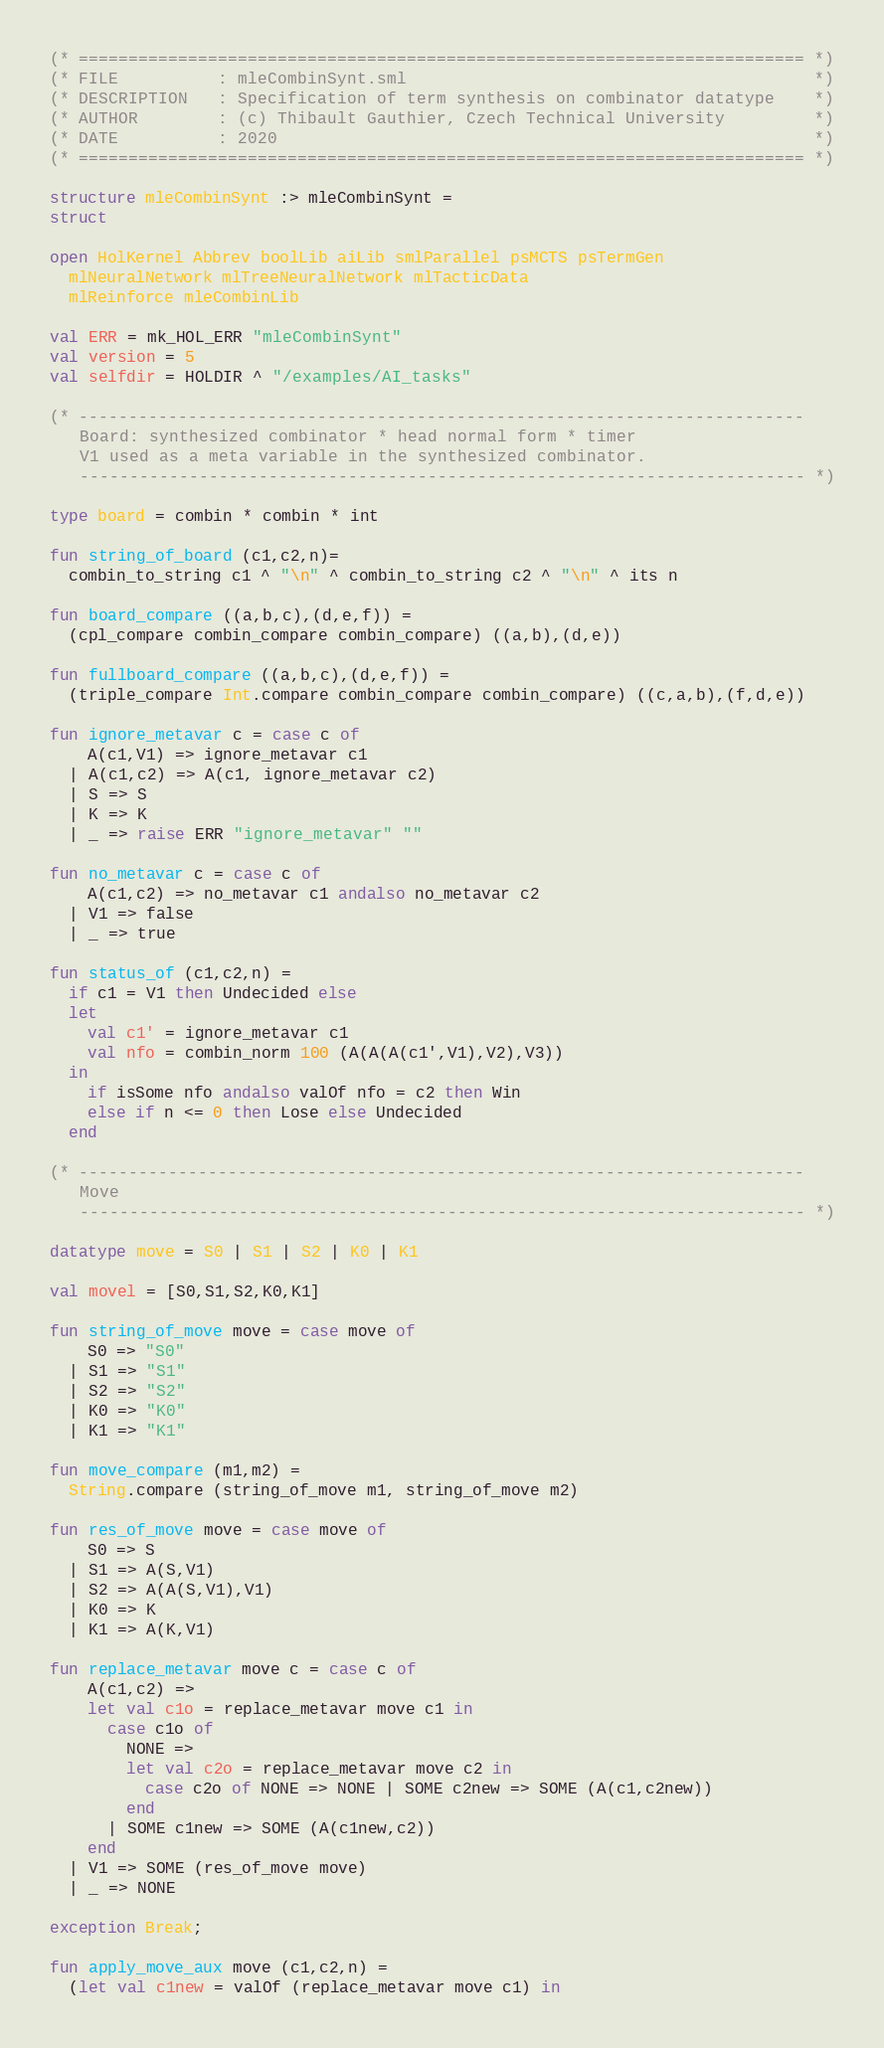Convert code to text. <code><loc_0><loc_0><loc_500><loc_500><_SML_>(* ========================================================================= *)
(* FILE          : mleCombinSynt.sml                                         *)
(* DESCRIPTION   : Specification of term synthesis on combinator datatype    *)
(* AUTHOR        : (c) Thibault Gauthier, Czech Technical University         *)
(* DATE          : 2020                                                      *)
(* ========================================================================= *)

structure mleCombinSynt :> mleCombinSynt =
struct

open HolKernel Abbrev boolLib aiLib smlParallel psMCTS psTermGen
  mlNeuralNetwork mlTreeNeuralNetwork mlTacticData
  mlReinforce mleCombinLib

val ERR = mk_HOL_ERR "mleCombinSynt"
val version = 5
val selfdir = HOLDIR ^ "/examples/AI_tasks"

(* -------------------------------------------------------------------------
   Board: synthesized combinator * head normal form * timer
   V1 used as a meta variable in the synthesized combinator.
   ------------------------------------------------------------------------- *)

type board = combin * combin * int

fun string_of_board (c1,c2,n)=
  combin_to_string c1 ^ "\n" ^ combin_to_string c2 ^ "\n" ^ its n

fun board_compare ((a,b,c),(d,e,f)) =
  (cpl_compare combin_compare combin_compare) ((a,b),(d,e))

fun fullboard_compare ((a,b,c),(d,e,f)) =
  (triple_compare Int.compare combin_compare combin_compare) ((c,a,b),(f,d,e))

fun ignore_metavar c = case c of
    A(c1,V1) => ignore_metavar c1
  | A(c1,c2) => A(c1, ignore_metavar c2)
  | S => S
  | K => K
  | _ => raise ERR "ignore_metavar" ""

fun no_metavar c = case c of
    A(c1,c2) => no_metavar c1 andalso no_metavar c2
  | V1 => false
  | _ => true

fun status_of (c1,c2,n) =
  if c1 = V1 then Undecided else
  let
    val c1' = ignore_metavar c1
    val nfo = combin_norm 100 (A(A(A(c1',V1),V2),V3))
  in
    if isSome nfo andalso valOf nfo = c2 then Win
    else if n <= 0 then Lose else Undecided
  end

(* -------------------------------------------------------------------------
   Move
   ------------------------------------------------------------------------- *)

datatype move = S0 | S1 | S2 | K0 | K1

val movel = [S0,S1,S2,K0,K1]

fun string_of_move move = case move of
    S0 => "S0"
  | S1 => "S1"
  | S2 => "S2"
  | K0 => "K0"
  | K1 => "K1"

fun move_compare (m1,m2) =
  String.compare (string_of_move m1, string_of_move m2)

fun res_of_move move = case move of
    S0 => S
  | S1 => A(S,V1)
  | S2 => A(A(S,V1),V1)
  | K0 => K
  | K1 => A(K,V1)

fun replace_metavar move c = case c of
    A(c1,c2) =>
    let val c1o = replace_metavar move c1 in
      case c1o of
        NONE =>
        let val c2o = replace_metavar move c2 in
          case c2o of NONE => NONE | SOME c2new => SOME (A(c1,c2new))
        end
      | SOME c1new => SOME (A(c1new,c2))
    end
  | V1 => SOME (res_of_move move)
  | _ => NONE

exception Break;

fun apply_move_aux move (c1,c2,n) =
  (let val c1new = valOf (replace_metavar move c1) in</code> 